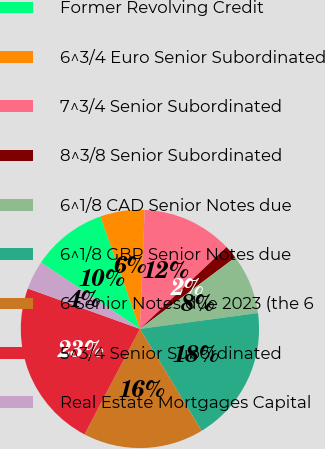<chart> <loc_0><loc_0><loc_500><loc_500><pie_chart><fcel>Former Revolving Credit<fcel>6^3/4 Euro Senior Subordinated<fcel>7^3/4 Senior Subordinated<fcel>8^3/8 Senior Subordinated<fcel>6^1/8 CAD Senior Notes due<fcel>6^1/8 GBP Senior Notes due<fcel>6 Senior Notes due 2023 (the 6<fcel>5^3/4 Senior Subordinated<fcel>Real Estate Mortgages Capital<nl><fcel>10.21%<fcel>6.01%<fcel>12.31%<fcel>1.81%<fcel>8.11%<fcel>18.46%<fcel>16.36%<fcel>22.81%<fcel>3.91%<nl></chart> 